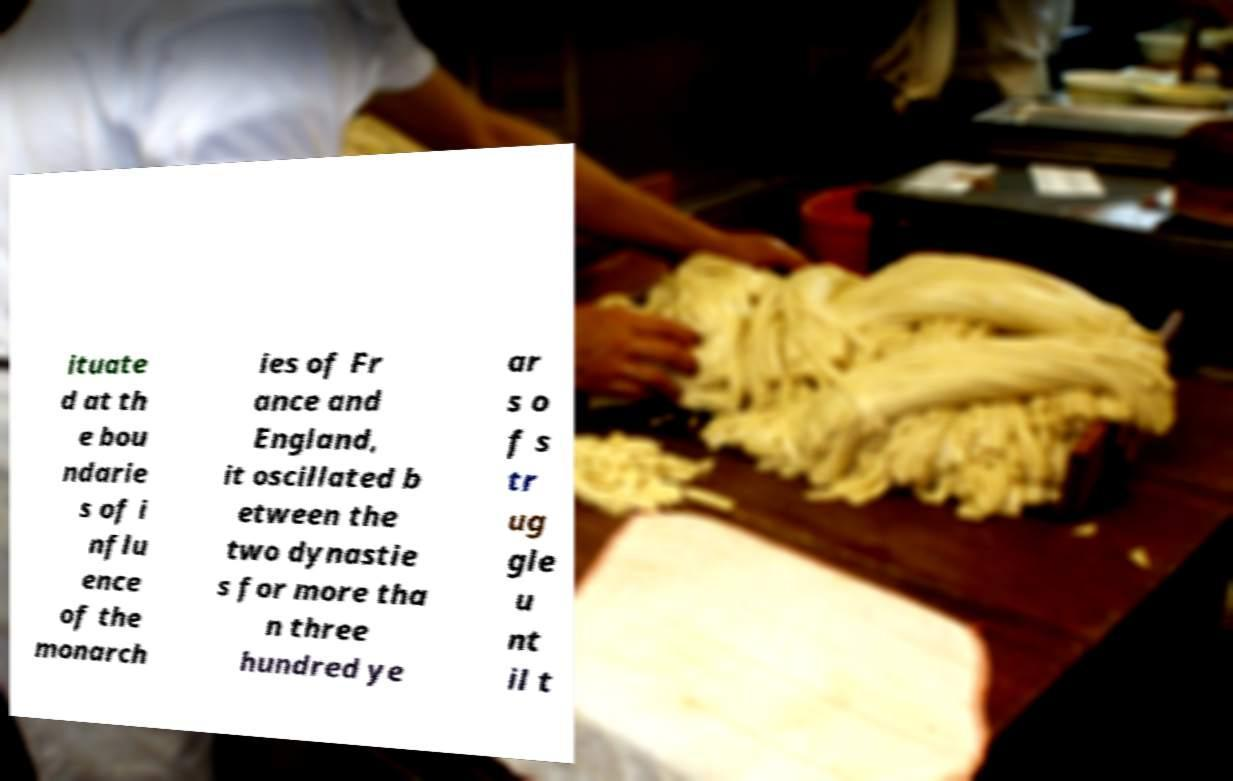For documentation purposes, I need the text within this image transcribed. Could you provide that? ituate d at th e bou ndarie s of i nflu ence of the monarch ies of Fr ance and England, it oscillated b etween the two dynastie s for more tha n three hundred ye ar s o f s tr ug gle u nt il t 